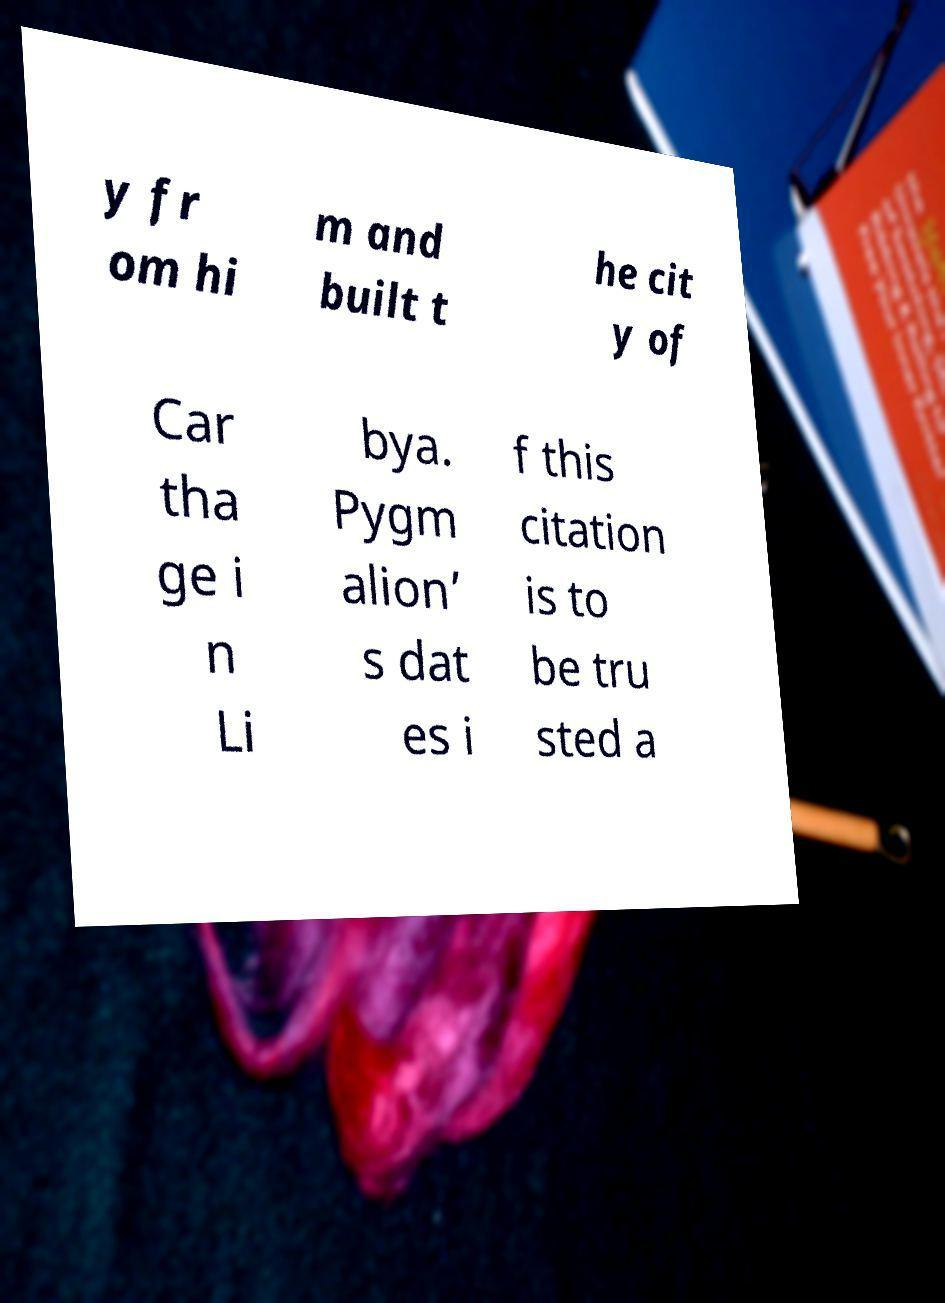Could you extract and type out the text from this image? y fr om hi m and built t he cit y of Car tha ge i n Li bya. Pygm alion’ s dat es i f this citation is to be tru sted a 